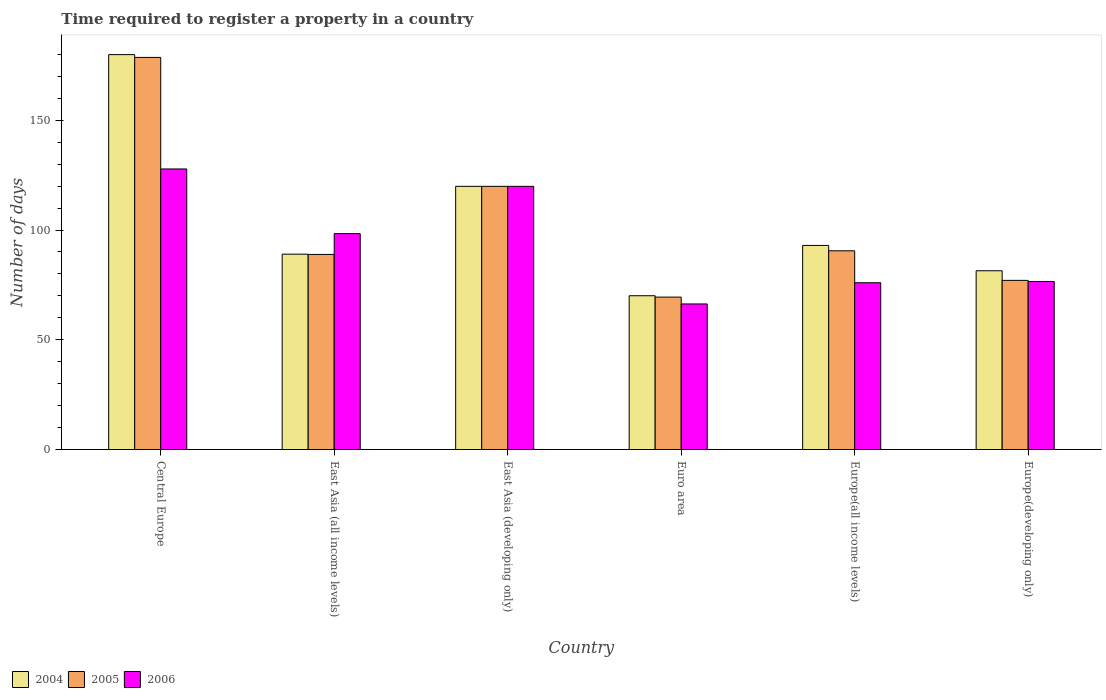How many groups of bars are there?
Keep it short and to the point. 6. Are the number of bars per tick equal to the number of legend labels?
Make the answer very short. Yes. What is the label of the 6th group of bars from the left?
Your response must be concise. Europe(developing only). What is the number of days required to register a property in 2004 in Central Europe?
Make the answer very short. 179.91. Across all countries, what is the maximum number of days required to register a property in 2006?
Provide a short and direct response. 127.82. Across all countries, what is the minimum number of days required to register a property in 2004?
Offer a terse response. 70.06. In which country was the number of days required to register a property in 2006 maximum?
Keep it short and to the point. Central Europe. In which country was the number of days required to register a property in 2006 minimum?
Your answer should be compact. Euro area. What is the total number of days required to register a property in 2006 in the graph?
Offer a very short reply. 564.95. What is the difference between the number of days required to register a property in 2005 in Euro area and that in Europe(developing only)?
Keep it short and to the point. -7.62. What is the difference between the number of days required to register a property in 2005 in Central Europe and the number of days required to register a property in 2006 in Europe(developing only)?
Provide a short and direct response. 102.08. What is the average number of days required to register a property in 2004 per country?
Provide a short and direct response. 105.55. What is the difference between the number of days required to register a property of/in 2004 and number of days required to register a property of/in 2006 in Central Europe?
Ensure brevity in your answer.  52.09. What is the ratio of the number of days required to register a property in 2006 in East Asia (all income levels) to that in Euro area?
Give a very brief answer. 1.48. Is the number of days required to register a property in 2004 in Central Europe less than that in Europe(developing only)?
Your answer should be compact. No. Is the difference between the number of days required to register a property in 2004 in Central Europe and Europe(developing only) greater than the difference between the number of days required to register a property in 2006 in Central Europe and Europe(developing only)?
Your answer should be very brief. Yes. What is the difference between the highest and the second highest number of days required to register a property in 2005?
Give a very brief answer. 88.1. What is the difference between the highest and the lowest number of days required to register a property in 2005?
Your response must be concise. 109.2. In how many countries, is the number of days required to register a property in 2004 greater than the average number of days required to register a property in 2004 taken over all countries?
Keep it short and to the point. 2. Is the sum of the number of days required to register a property in 2006 in East Asia (all income levels) and Euro area greater than the maximum number of days required to register a property in 2005 across all countries?
Keep it short and to the point. No. What does the 3rd bar from the right in East Asia (all income levels) represents?
Keep it short and to the point. 2004. Are all the bars in the graph horizontal?
Keep it short and to the point. No. What is the difference between two consecutive major ticks on the Y-axis?
Provide a succinct answer. 50. Does the graph contain any zero values?
Provide a succinct answer. No. What is the title of the graph?
Your answer should be very brief. Time required to register a property in a country. Does "1997" appear as one of the legend labels in the graph?
Offer a very short reply. No. What is the label or title of the Y-axis?
Make the answer very short. Number of days. What is the Number of days of 2004 in Central Europe?
Ensure brevity in your answer.  179.91. What is the Number of days in 2005 in Central Europe?
Give a very brief answer. 178.64. What is the Number of days of 2006 in Central Europe?
Provide a succinct answer. 127.82. What is the Number of days in 2004 in East Asia (all income levels)?
Provide a succinct answer. 89. What is the Number of days in 2005 in East Asia (all income levels)?
Make the answer very short. 88.88. What is the Number of days in 2006 in East Asia (all income levels)?
Your answer should be very brief. 98.36. What is the Number of days in 2004 in East Asia (developing only)?
Ensure brevity in your answer.  119.9. What is the Number of days in 2005 in East Asia (developing only)?
Provide a short and direct response. 119.9. What is the Number of days in 2006 in East Asia (developing only)?
Your answer should be compact. 119.9. What is the Number of days in 2004 in Euro area?
Ensure brevity in your answer.  70.06. What is the Number of days of 2005 in Euro area?
Ensure brevity in your answer.  69.44. What is the Number of days of 2006 in Euro area?
Your response must be concise. 66.32. What is the Number of days of 2004 in Europe(all income levels)?
Your answer should be compact. 92.98. What is the Number of days in 2005 in Europe(all income levels)?
Provide a short and direct response. 90.53. What is the Number of days in 2006 in Europe(all income levels)?
Make the answer very short. 75.99. What is the Number of days in 2004 in Europe(developing only)?
Make the answer very short. 81.44. What is the Number of days in 2005 in Europe(developing only)?
Offer a terse response. 77.06. What is the Number of days of 2006 in Europe(developing only)?
Offer a very short reply. 76.56. Across all countries, what is the maximum Number of days of 2004?
Your response must be concise. 179.91. Across all countries, what is the maximum Number of days of 2005?
Your response must be concise. 178.64. Across all countries, what is the maximum Number of days of 2006?
Provide a short and direct response. 127.82. Across all countries, what is the minimum Number of days of 2004?
Offer a very short reply. 70.06. Across all countries, what is the minimum Number of days in 2005?
Your answer should be very brief. 69.44. Across all countries, what is the minimum Number of days of 2006?
Make the answer very short. 66.32. What is the total Number of days of 2004 in the graph?
Ensure brevity in your answer.  633.29. What is the total Number of days of 2005 in the graph?
Provide a short and direct response. 624.45. What is the total Number of days in 2006 in the graph?
Your answer should be very brief. 564.95. What is the difference between the Number of days in 2004 in Central Europe and that in East Asia (all income levels)?
Your response must be concise. 90.91. What is the difference between the Number of days of 2005 in Central Europe and that in East Asia (all income levels)?
Make the answer very short. 89.76. What is the difference between the Number of days in 2006 in Central Europe and that in East Asia (all income levels)?
Keep it short and to the point. 29.45. What is the difference between the Number of days in 2004 in Central Europe and that in East Asia (developing only)?
Your response must be concise. 60.01. What is the difference between the Number of days in 2005 in Central Europe and that in East Asia (developing only)?
Your answer should be compact. 58.74. What is the difference between the Number of days in 2006 in Central Europe and that in East Asia (developing only)?
Your answer should be compact. 7.92. What is the difference between the Number of days of 2004 in Central Europe and that in Euro area?
Make the answer very short. 109.85. What is the difference between the Number of days of 2005 in Central Europe and that in Euro area?
Your answer should be compact. 109.2. What is the difference between the Number of days of 2006 in Central Europe and that in Euro area?
Your answer should be compact. 61.49. What is the difference between the Number of days of 2004 in Central Europe and that in Europe(all income levels)?
Give a very brief answer. 86.93. What is the difference between the Number of days in 2005 in Central Europe and that in Europe(all income levels)?
Provide a succinct answer. 88.1. What is the difference between the Number of days of 2006 in Central Europe and that in Europe(all income levels)?
Offer a very short reply. 51.83. What is the difference between the Number of days in 2004 in Central Europe and that in Europe(developing only)?
Your response must be concise. 98.47. What is the difference between the Number of days in 2005 in Central Europe and that in Europe(developing only)?
Give a very brief answer. 101.58. What is the difference between the Number of days of 2006 in Central Europe and that in Europe(developing only)?
Provide a short and direct response. 51.26. What is the difference between the Number of days of 2004 in East Asia (all income levels) and that in East Asia (developing only)?
Provide a short and direct response. -30.9. What is the difference between the Number of days of 2005 in East Asia (all income levels) and that in East Asia (developing only)?
Provide a short and direct response. -31.02. What is the difference between the Number of days of 2006 in East Asia (all income levels) and that in East Asia (developing only)?
Provide a succinct answer. -21.54. What is the difference between the Number of days in 2004 in East Asia (all income levels) and that in Euro area?
Keep it short and to the point. 18.94. What is the difference between the Number of days in 2005 in East Asia (all income levels) and that in Euro area?
Offer a very short reply. 19.44. What is the difference between the Number of days of 2006 in East Asia (all income levels) and that in Euro area?
Provide a short and direct response. 32.04. What is the difference between the Number of days of 2004 in East Asia (all income levels) and that in Europe(all income levels)?
Ensure brevity in your answer.  -3.98. What is the difference between the Number of days of 2005 in East Asia (all income levels) and that in Europe(all income levels)?
Your answer should be very brief. -1.65. What is the difference between the Number of days in 2006 in East Asia (all income levels) and that in Europe(all income levels)?
Provide a succinct answer. 22.37. What is the difference between the Number of days in 2004 in East Asia (all income levels) and that in Europe(developing only)?
Your response must be concise. 7.56. What is the difference between the Number of days in 2005 in East Asia (all income levels) and that in Europe(developing only)?
Make the answer very short. 11.82. What is the difference between the Number of days in 2006 in East Asia (all income levels) and that in Europe(developing only)?
Keep it short and to the point. 21.81. What is the difference between the Number of days in 2004 in East Asia (developing only) and that in Euro area?
Provide a succinct answer. 49.84. What is the difference between the Number of days in 2005 in East Asia (developing only) and that in Euro area?
Provide a short and direct response. 50.46. What is the difference between the Number of days in 2006 in East Asia (developing only) and that in Euro area?
Ensure brevity in your answer.  53.58. What is the difference between the Number of days in 2004 in East Asia (developing only) and that in Europe(all income levels)?
Offer a very short reply. 26.92. What is the difference between the Number of days in 2005 in East Asia (developing only) and that in Europe(all income levels)?
Offer a terse response. 29.37. What is the difference between the Number of days in 2006 in East Asia (developing only) and that in Europe(all income levels)?
Keep it short and to the point. 43.91. What is the difference between the Number of days in 2004 in East Asia (developing only) and that in Europe(developing only)?
Your answer should be very brief. 38.46. What is the difference between the Number of days of 2005 in East Asia (developing only) and that in Europe(developing only)?
Your answer should be compact. 42.84. What is the difference between the Number of days in 2006 in East Asia (developing only) and that in Europe(developing only)?
Your answer should be compact. 43.34. What is the difference between the Number of days of 2004 in Euro area and that in Europe(all income levels)?
Your answer should be compact. -22.91. What is the difference between the Number of days of 2005 in Euro area and that in Europe(all income levels)?
Keep it short and to the point. -21.1. What is the difference between the Number of days in 2006 in Euro area and that in Europe(all income levels)?
Ensure brevity in your answer.  -9.67. What is the difference between the Number of days of 2004 in Euro area and that in Europe(developing only)?
Provide a succinct answer. -11.38. What is the difference between the Number of days in 2005 in Euro area and that in Europe(developing only)?
Your answer should be compact. -7.62. What is the difference between the Number of days in 2006 in Euro area and that in Europe(developing only)?
Your answer should be compact. -10.23. What is the difference between the Number of days of 2004 in Europe(all income levels) and that in Europe(developing only)?
Make the answer very short. 11.54. What is the difference between the Number of days in 2005 in Europe(all income levels) and that in Europe(developing only)?
Your answer should be very brief. 13.48. What is the difference between the Number of days of 2006 in Europe(all income levels) and that in Europe(developing only)?
Ensure brevity in your answer.  -0.57. What is the difference between the Number of days of 2004 in Central Europe and the Number of days of 2005 in East Asia (all income levels)?
Your answer should be very brief. 91.03. What is the difference between the Number of days in 2004 in Central Europe and the Number of days in 2006 in East Asia (all income levels)?
Ensure brevity in your answer.  81.55. What is the difference between the Number of days in 2005 in Central Europe and the Number of days in 2006 in East Asia (all income levels)?
Give a very brief answer. 80.27. What is the difference between the Number of days of 2004 in Central Europe and the Number of days of 2005 in East Asia (developing only)?
Provide a succinct answer. 60.01. What is the difference between the Number of days in 2004 in Central Europe and the Number of days in 2006 in East Asia (developing only)?
Offer a very short reply. 60.01. What is the difference between the Number of days of 2005 in Central Europe and the Number of days of 2006 in East Asia (developing only)?
Provide a short and direct response. 58.74. What is the difference between the Number of days of 2004 in Central Europe and the Number of days of 2005 in Euro area?
Give a very brief answer. 110.47. What is the difference between the Number of days of 2004 in Central Europe and the Number of days of 2006 in Euro area?
Your answer should be compact. 113.59. What is the difference between the Number of days in 2005 in Central Europe and the Number of days in 2006 in Euro area?
Provide a succinct answer. 112.31. What is the difference between the Number of days in 2004 in Central Europe and the Number of days in 2005 in Europe(all income levels)?
Provide a short and direct response. 89.37. What is the difference between the Number of days in 2004 in Central Europe and the Number of days in 2006 in Europe(all income levels)?
Offer a very short reply. 103.92. What is the difference between the Number of days in 2005 in Central Europe and the Number of days in 2006 in Europe(all income levels)?
Your response must be concise. 102.65. What is the difference between the Number of days of 2004 in Central Europe and the Number of days of 2005 in Europe(developing only)?
Your answer should be compact. 102.85. What is the difference between the Number of days in 2004 in Central Europe and the Number of days in 2006 in Europe(developing only)?
Provide a short and direct response. 103.35. What is the difference between the Number of days of 2005 in Central Europe and the Number of days of 2006 in Europe(developing only)?
Provide a succinct answer. 102.08. What is the difference between the Number of days in 2004 in East Asia (all income levels) and the Number of days in 2005 in East Asia (developing only)?
Your answer should be compact. -30.9. What is the difference between the Number of days in 2004 in East Asia (all income levels) and the Number of days in 2006 in East Asia (developing only)?
Provide a succinct answer. -30.9. What is the difference between the Number of days in 2005 in East Asia (all income levels) and the Number of days in 2006 in East Asia (developing only)?
Your response must be concise. -31.02. What is the difference between the Number of days in 2004 in East Asia (all income levels) and the Number of days in 2005 in Euro area?
Give a very brief answer. 19.56. What is the difference between the Number of days in 2004 in East Asia (all income levels) and the Number of days in 2006 in Euro area?
Offer a terse response. 22.68. What is the difference between the Number of days in 2005 in East Asia (all income levels) and the Number of days in 2006 in Euro area?
Keep it short and to the point. 22.56. What is the difference between the Number of days in 2004 in East Asia (all income levels) and the Number of days in 2005 in Europe(all income levels)?
Your response must be concise. -1.53. What is the difference between the Number of days in 2004 in East Asia (all income levels) and the Number of days in 2006 in Europe(all income levels)?
Offer a terse response. 13.01. What is the difference between the Number of days in 2005 in East Asia (all income levels) and the Number of days in 2006 in Europe(all income levels)?
Offer a very short reply. 12.89. What is the difference between the Number of days of 2004 in East Asia (all income levels) and the Number of days of 2005 in Europe(developing only)?
Offer a terse response. 11.94. What is the difference between the Number of days of 2004 in East Asia (all income levels) and the Number of days of 2006 in Europe(developing only)?
Offer a terse response. 12.44. What is the difference between the Number of days in 2005 in East Asia (all income levels) and the Number of days in 2006 in Europe(developing only)?
Provide a succinct answer. 12.33. What is the difference between the Number of days of 2004 in East Asia (developing only) and the Number of days of 2005 in Euro area?
Your answer should be compact. 50.46. What is the difference between the Number of days in 2004 in East Asia (developing only) and the Number of days in 2006 in Euro area?
Keep it short and to the point. 53.58. What is the difference between the Number of days of 2005 in East Asia (developing only) and the Number of days of 2006 in Euro area?
Your answer should be very brief. 53.58. What is the difference between the Number of days in 2004 in East Asia (developing only) and the Number of days in 2005 in Europe(all income levels)?
Provide a succinct answer. 29.37. What is the difference between the Number of days in 2004 in East Asia (developing only) and the Number of days in 2006 in Europe(all income levels)?
Your answer should be compact. 43.91. What is the difference between the Number of days of 2005 in East Asia (developing only) and the Number of days of 2006 in Europe(all income levels)?
Your answer should be very brief. 43.91. What is the difference between the Number of days in 2004 in East Asia (developing only) and the Number of days in 2005 in Europe(developing only)?
Make the answer very short. 42.84. What is the difference between the Number of days of 2004 in East Asia (developing only) and the Number of days of 2006 in Europe(developing only)?
Your response must be concise. 43.34. What is the difference between the Number of days of 2005 in East Asia (developing only) and the Number of days of 2006 in Europe(developing only)?
Give a very brief answer. 43.34. What is the difference between the Number of days of 2004 in Euro area and the Number of days of 2005 in Europe(all income levels)?
Keep it short and to the point. -20.47. What is the difference between the Number of days of 2004 in Euro area and the Number of days of 2006 in Europe(all income levels)?
Your answer should be very brief. -5.93. What is the difference between the Number of days in 2005 in Euro area and the Number of days in 2006 in Europe(all income levels)?
Provide a short and direct response. -6.55. What is the difference between the Number of days in 2004 in Euro area and the Number of days in 2005 in Europe(developing only)?
Your response must be concise. -7. What is the difference between the Number of days of 2004 in Euro area and the Number of days of 2006 in Europe(developing only)?
Make the answer very short. -6.49. What is the difference between the Number of days of 2005 in Euro area and the Number of days of 2006 in Europe(developing only)?
Give a very brief answer. -7.12. What is the difference between the Number of days of 2004 in Europe(all income levels) and the Number of days of 2005 in Europe(developing only)?
Make the answer very short. 15.92. What is the difference between the Number of days in 2004 in Europe(all income levels) and the Number of days in 2006 in Europe(developing only)?
Your answer should be compact. 16.42. What is the difference between the Number of days of 2005 in Europe(all income levels) and the Number of days of 2006 in Europe(developing only)?
Give a very brief answer. 13.98. What is the average Number of days in 2004 per country?
Keep it short and to the point. 105.55. What is the average Number of days in 2005 per country?
Your answer should be compact. 104.07. What is the average Number of days of 2006 per country?
Your response must be concise. 94.16. What is the difference between the Number of days of 2004 and Number of days of 2005 in Central Europe?
Keep it short and to the point. 1.27. What is the difference between the Number of days of 2004 and Number of days of 2006 in Central Europe?
Keep it short and to the point. 52.09. What is the difference between the Number of days in 2005 and Number of days in 2006 in Central Europe?
Make the answer very short. 50.82. What is the difference between the Number of days of 2004 and Number of days of 2005 in East Asia (all income levels)?
Provide a succinct answer. 0.12. What is the difference between the Number of days in 2004 and Number of days in 2006 in East Asia (all income levels)?
Give a very brief answer. -9.36. What is the difference between the Number of days in 2005 and Number of days in 2006 in East Asia (all income levels)?
Provide a short and direct response. -9.48. What is the difference between the Number of days of 2004 and Number of days of 2006 in East Asia (developing only)?
Your response must be concise. 0. What is the difference between the Number of days in 2004 and Number of days in 2005 in Euro area?
Your answer should be compact. 0.62. What is the difference between the Number of days in 2004 and Number of days in 2006 in Euro area?
Your answer should be very brief. 3.74. What is the difference between the Number of days of 2005 and Number of days of 2006 in Euro area?
Your answer should be very brief. 3.11. What is the difference between the Number of days of 2004 and Number of days of 2005 in Europe(all income levels)?
Ensure brevity in your answer.  2.44. What is the difference between the Number of days in 2004 and Number of days in 2006 in Europe(all income levels)?
Provide a short and direct response. 16.99. What is the difference between the Number of days of 2005 and Number of days of 2006 in Europe(all income levels)?
Offer a very short reply. 14.55. What is the difference between the Number of days of 2004 and Number of days of 2005 in Europe(developing only)?
Your response must be concise. 4.38. What is the difference between the Number of days of 2004 and Number of days of 2006 in Europe(developing only)?
Provide a succinct answer. 4.88. What is the difference between the Number of days of 2005 and Number of days of 2006 in Europe(developing only)?
Keep it short and to the point. 0.5. What is the ratio of the Number of days of 2004 in Central Europe to that in East Asia (all income levels)?
Ensure brevity in your answer.  2.02. What is the ratio of the Number of days in 2005 in Central Europe to that in East Asia (all income levels)?
Offer a terse response. 2.01. What is the ratio of the Number of days in 2006 in Central Europe to that in East Asia (all income levels)?
Keep it short and to the point. 1.3. What is the ratio of the Number of days of 2004 in Central Europe to that in East Asia (developing only)?
Ensure brevity in your answer.  1.5. What is the ratio of the Number of days of 2005 in Central Europe to that in East Asia (developing only)?
Offer a very short reply. 1.49. What is the ratio of the Number of days in 2006 in Central Europe to that in East Asia (developing only)?
Ensure brevity in your answer.  1.07. What is the ratio of the Number of days of 2004 in Central Europe to that in Euro area?
Provide a short and direct response. 2.57. What is the ratio of the Number of days of 2005 in Central Europe to that in Euro area?
Keep it short and to the point. 2.57. What is the ratio of the Number of days of 2006 in Central Europe to that in Euro area?
Offer a terse response. 1.93. What is the ratio of the Number of days in 2004 in Central Europe to that in Europe(all income levels)?
Your answer should be very brief. 1.94. What is the ratio of the Number of days of 2005 in Central Europe to that in Europe(all income levels)?
Your response must be concise. 1.97. What is the ratio of the Number of days in 2006 in Central Europe to that in Europe(all income levels)?
Your answer should be very brief. 1.68. What is the ratio of the Number of days in 2004 in Central Europe to that in Europe(developing only)?
Your response must be concise. 2.21. What is the ratio of the Number of days of 2005 in Central Europe to that in Europe(developing only)?
Offer a terse response. 2.32. What is the ratio of the Number of days in 2006 in Central Europe to that in Europe(developing only)?
Offer a very short reply. 1.67. What is the ratio of the Number of days of 2004 in East Asia (all income levels) to that in East Asia (developing only)?
Provide a short and direct response. 0.74. What is the ratio of the Number of days of 2005 in East Asia (all income levels) to that in East Asia (developing only)?
Offer a very short reply. 0.74. What is the ratio of the Number of days of 2006 in East Asia (all income levels) to that in East Asia (developing only)?
Your answer should be very brief. 0.82. What is the ratio of the Number of days in 2004 in East Asia (all income levels) to that in Euro area?
Ensure brevity in your answer.  1.27. What is the ratio of the Number of days of 2005 in East Asia (all income levels) to that in Euro area?
Provide a succinct answer. 1.28. What is the ratio of the Number of days in 2006 in East Asia (all income levels) to that in Euro area?
Ensure brevity in your answer.  1.48. What is the ratio of the Number of days of 2004 in East Asia (all income levels) to that in Europe(all income levels)?
Give a very brief answer. 0.96. What is the ratio of the Number of days in 2005 in East Asia (all income levels) to that in Europe(all income levels)?
Make the answer very short. 0.98. What is the ratio of the Number of days in 2006 in East Asia (all income levels) to that in Europe(all income levels)?
Your answer should be compact. 1.29. What is the ratio of the Number of days of 2004 in East Asia (all income levels) to that in Europe(developing only)?
Keep it short and to the point. 1.09. What is the ratio of the Number of days in 2005 in East Asia (all income levels) to that in Europe(developing only)?
Keep it short and to the point. 1.15. What is the ratio of the Number of days of 2006 in East Asia (all income levels) to that in Europe(developing only)?
Offer a very short reply. 1.28. What is the ratio of the Number of days in 2004 in East Asia (developing only) to that in Euro area?
Provide a succinct answer. 1.71. What is the ratio of the Number of days in 2005 in East Asia (developing only) to that in Euro area?
Provide a short and direct response. 1.73. What is the ratio of the Number of days of 2006 in East Asia (developing only) to that in Euro area?
Your response must be concise. 1.81. What is the ratio of the Number of days in 2004 in East Asia (developing only) to that in Europe(all income levels)?
Offer a very short reply. 1.29. What is the ratio of the Number of days of 2005 in East Asia (developing only) to that in Europe(all income levels)?
Offer a terse response. 1.32. What is the ratio of the Number of days of 2006 in East Asia (developing only) to that in Europe(all income levels)?
Ensure brevity in your answer.  1.58. What is the ratio of the Number of days of 2004 in East Asia (developing only) to that in Europe(developing only)?
Your answer should be compact. 1.47. What is the ratio of the Number of days of 2005 in East Asia (developing only) to that in Europe(developing only)?
Offer a terse response. 1.56. What is the ratio of the Number of days of 2006 in East Asia (developing only) to that in Europe(developing only)?
Keep it short and to the point. 1.57. What is the ratio of the Number of days in 2004 in Euro area to that in Europe(all income levels)?
Give a very brief answer. 0.75. What is the ratio of the Number of days of 2005 in Euro area to that in Europe(all income levels)?
Your answer should be compact. 0.77. What is the ratio of the Number of days in 2006 in Euro area to that in Europe(all income levels)?
Offer a very short reply. 0.87. What is the ratio of the Number of days in 2004 in Euro area to that in Europe(developing only)?
Make the answer very short. 0.86. What is the ratio of the Number of days in 2005 in Euro area to that in Europe(developing only)?
Ensure brevity in your answer.  0.9. What is the ratio of the Number of days in 2006 in Euro area to that in Europe(developing only)?
Offer a very short reply. 0.87. What is the ratio of the Number of days in 2004 in Europe(all income levels) to that in Europe(developing only)?
Give a very brief answer. 1.14. What is the ratio of the Number of days of 2005 in Europe(all income levels) to that in Europe(developing only)?
Provide a short and direct response. 1.17. What is the difference between the highest and the second highest Number of days in 2004?
Your response must be concise. 60.01. What is the difference between the highest and the second highest Number of days of 2005?
Make the answer very short. 58.74. What is the difference between the highest and the second highest Number of days in 2006?
Your response must be concise. 7.92. What is the difference between the highest and the lowest Number of days in 2004?
Provide a succinct answer. 109.85. What is the difference between the highest and the lowest Number of days in 2005?
Provide a succinct answer. 109.2. What is the difference between the highest and the lowest Number of days in 2006?
Provide a short and direct response. 61.49. 